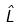Convert formula to latex. <formula><loc_0><loc_0><loc_500><loc_500>\hat { L }</formula> 